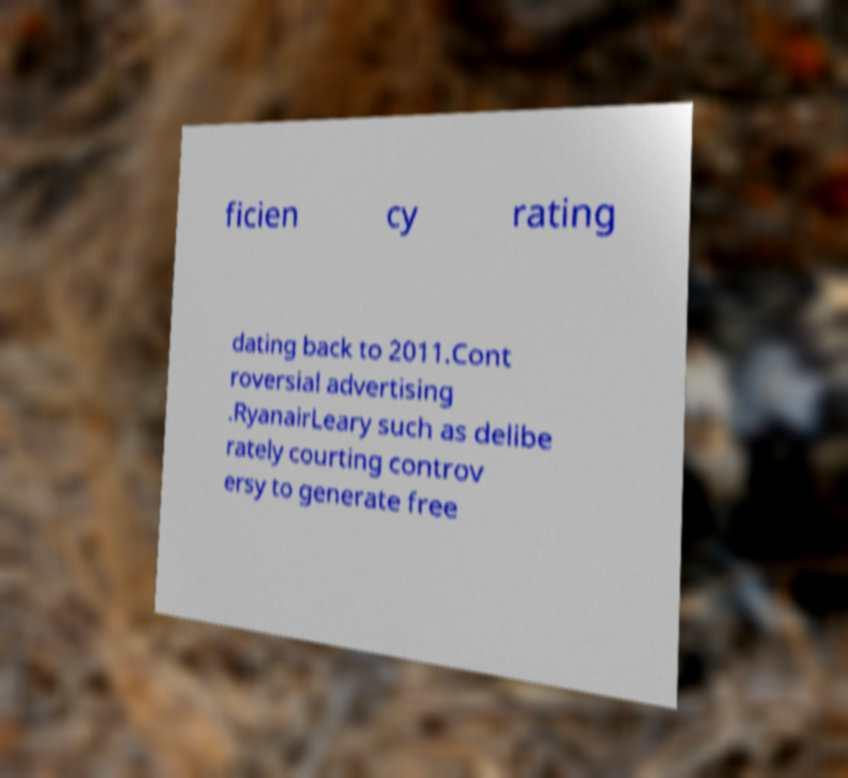Could you assist in decoding the text presented in this image and type it out clearly? ficien cy rating dating back to 2011.Cont roversial advertising .RyanairLeary such as delibe rately courting controv ersy to generate free 